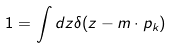<formula> <loc_0><loc_0><loc_500><loc_500>1 = \int d z \delta ( z - m \cdot p _ { k } )</formula> 